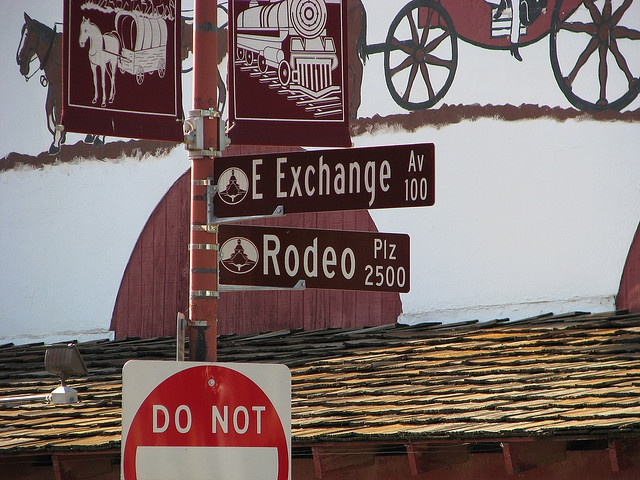Describe the objects in this image and their specific colors. I can see train in darkgray, maroon, black, and lightgray tones and horse in darkgray, black, and gray tones in this image. 